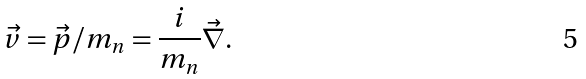Convert formula to latex. <formula><loc_0><loc_0><loc_500><loc_500>\vec { v } = \vec { p } / m _ { n } = { \frac { i } { m _ { n } } } \vec { \nabla } .</formula> 